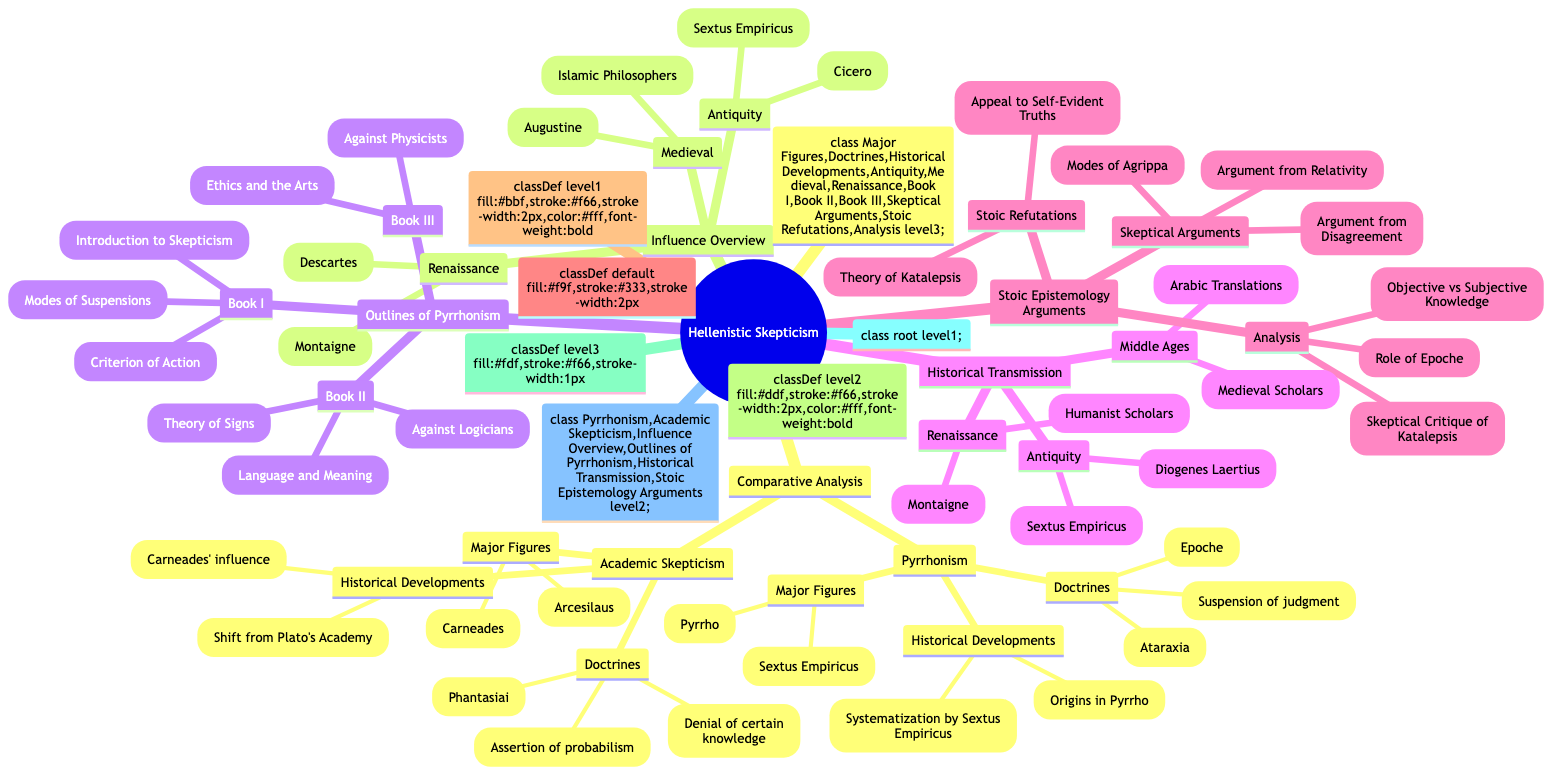What are the major figures in Pyrrhonism? The diagram lists "Pyrrho" and "Sextus Empiricus" under the "Major Figures" node of Pyrrhonism.
Answer: Pyrrho, Sextus Empiricus How many doctrines are associated with Academic Skepticism? The diagram identifies three doctrines under Academic Skepticism: assertion of probabilism, denial of certain knowledge, and phantasiai.
Answer: 3 Which historical figure influenced both Hellenistic skepticism and Renaissance thinkers? The diagram connects "Cicero" within the "Antiquity" section of the Influence Overview to later philosophical movements, indicating his significant role.
Answer: Cicero What is the title of Book I in Sextus Empiricus’ work? The diagram indicates that the title of Book I is "Introduction to Skepticism".
Answer: Introduction to Skepticism What argument from disagreement is associated with skeptical arguments against Stoic epistemology? Under the Stoic Epistemology Arguments, "Argument from Disagreement" is specifically mentioned as a skeptical argument.
Answer: Argument from Disagreement How many main historical periods does the diagram outline for the influence of Hellenistic skepticism? The Influence Overview section is divided into three main historical periods: Antiquity, Medieval, and Renaissance.
Answer: 3 What major doctrine is shared by both Pyrrhonism and Academic Skepticism? The diagram does not specify a shared doctrine directly; thus, reasoning through the doctrines shows that both emphasize some degree of suspension of judgment or epistemic doubt.
Answer: Suspension of judgment Which two major figures are featured in the Historical Transmission section? In both Antiquity, the diagram identifies "Sextus Empiricus" and "Diogenes Laertius" as key figures in the Historical Transmission section.
Answer: Sextus Empiricus, Diogenes Laertius What does the term "Ataraxia" represent in Pyrrhonism? The diagram lists "Ataraxia" under the doctrines of Pyrrhonism, indicating its significance in the philosophical framework of achieving tranquility.
Answer: Ataraxia 